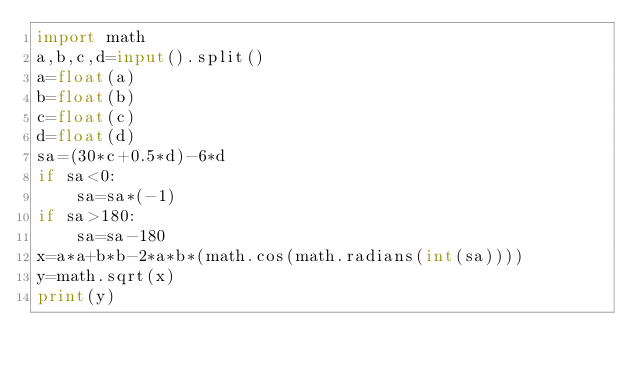<code> <loc_0><loc_0><loc_500><loc_500><_Python_>import math
a,b,c,d=input().split()
a=float(a)
b=float(b)
c=float(c)
d=float(d)
sa=(30*c+0.5*d)-6*d
if sa<0:
    sa=sa*(-1)
if sa>180:
    sa=sa-180
x=a*a+b*b-2*a*b*(math.cos(math.radians(int(sa))))
y=math.sqrt(x)
print(y)</code> 